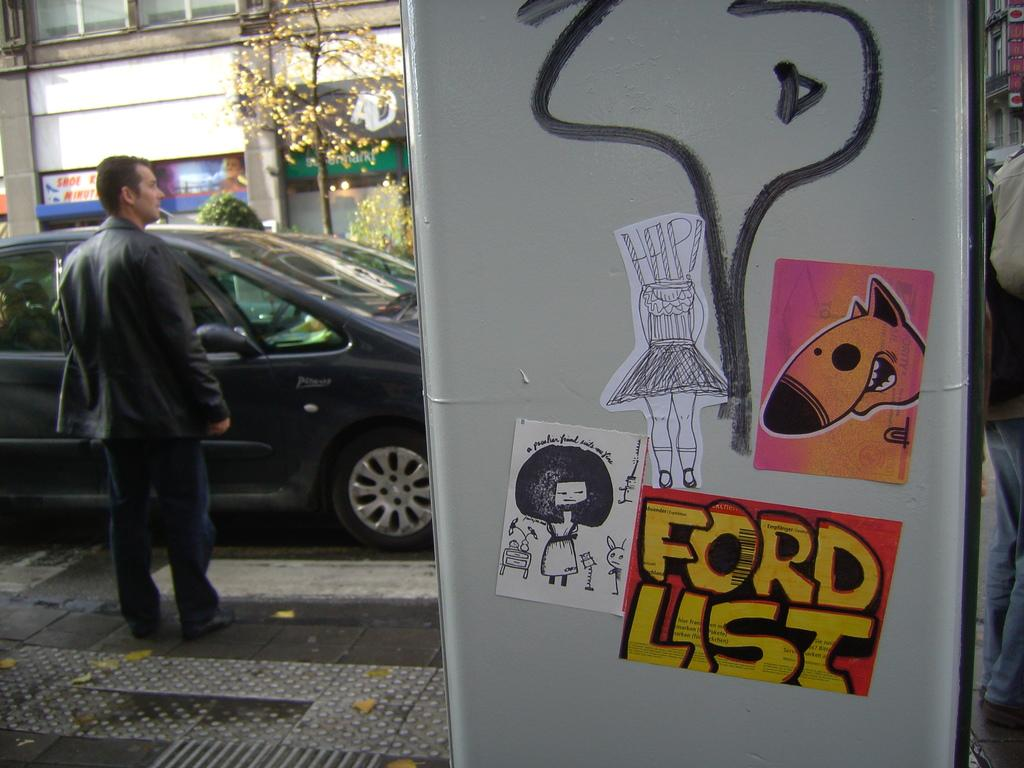What is on the wall to the right side of the image? There are stickers on the wall to the right side of the image. What can be seen in the image besides the stickers? There is a car and plants visible in the image. What is in the background of the image? There is a building in the background of the image. What type of animal is using the calculator in the image? There is no animal or calculator present in the image. What is the lumber being used for in the image? There is no lumber present in the image. 